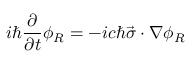Convert formula to latex. <formula><loc_0><loc_0><loc_500><loc_500>i \hbar { } \partial } { \partial t } \phi _ { R } = - i c \hbar { \vec } { \sigma } \cdot \nabla \phi _ { R }</formula> 